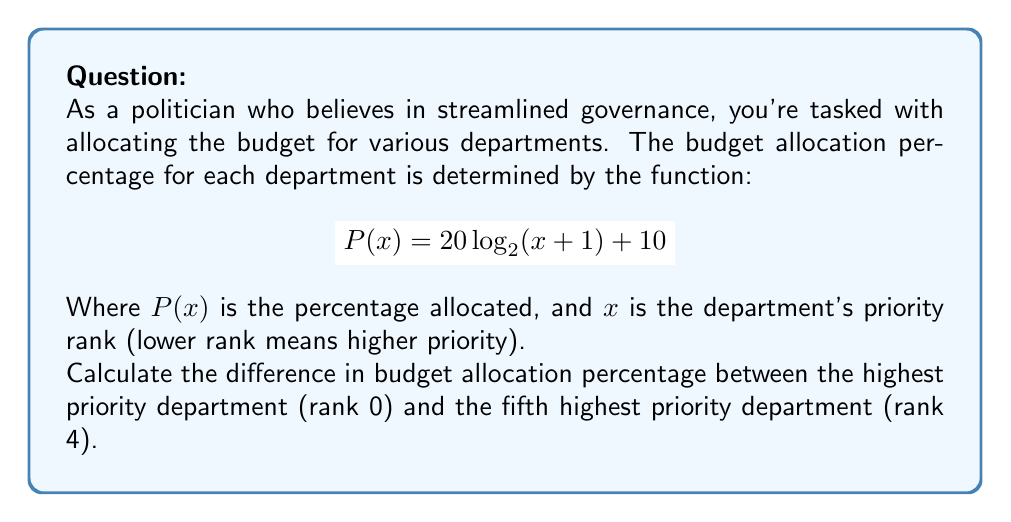Can you answer this question? Let's approach this step-by-step:

1) For the highest priority department (rank 0):
   $$P(0) = 20 \log_{2}(0 + 1) + 10$$
   $$P(0) = 20 \log_{2}(1) + 10$$
   $$P(0) = 20 \cdot 0 + 10 = 10\%$$

2) For the fifth highest priority department (rank 4):
   $$P(4) = 20 \log_{2}(4 + 1) + 10$$
   $$P(4) = 20 \log_{2}(5) + 10$$
   $$P(4) = 20 \cdot \log_{2}(5) + 10$$
   $$P(4) \approx 20 \cdot 2.322 + 10 \approx 56.44\%$$

3) The difference in allocation percentage:
   $$\text{Difference} = P(4) - P(0)$$
   $$\text{Difference} \approx 56.44 - 10 = 46.44\%$$
Answer: 46.44% 